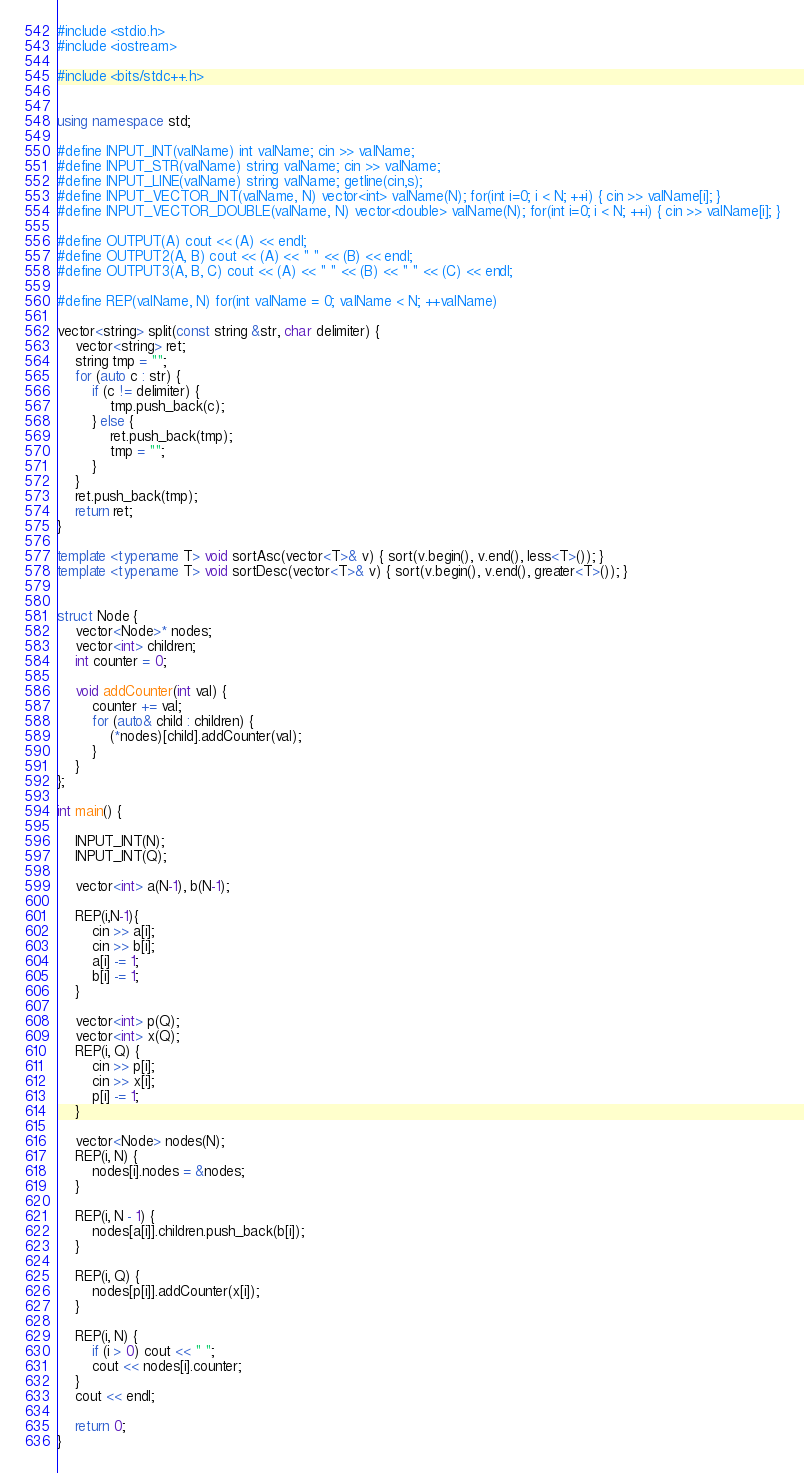Convert code to text. <code><loc_0><loc_0><loc_500><loc_500><_C++_>#include <stdio.h>
#include <iostream>

#include <bits/stdc++.h>


using namespace std;

#define INPUT_INT(valName) int valName; cin >> valName;
#define INPUT_STR(valName) string valName; cin >> valName;
#define INPUT_LINE(valName) string valName; getline(cin,s);
#define INPUT_VECTOR_INT(valName, N) vector<int> valName(N); for(int i=0; i < N; ++i) { cin >> valName[i]; }
#define INPUT_VECTOR_DOUBLE(valName, N) vector<double> valName(N); for(int i=0; i < N; ++i) { cin >> valName[i]; }

#define OUTPUT(A) cout << (A) << endl;
#define OUTPUT2(A, B) cout << (A) << " " << (B) << endl;
#define OUTPUT3(A, B, C) cout << (A) << " " << (B) << " " << (C) << endl;

#define REP(valName, N) for(int valName = 0; valName < N; ++valName)

vector<string> split(const string &str, char delimiter) {
	vector<string> ret;
	string tmp = "";
	for (auto c : str) {
		if (c != delimiter) {
			tmp.push_back(c);
		} else {
			ret.push_back(tmp);
			tmp = "";
		}
	}
	ret.push_back(tmp);
	return ret;
}

template <typename T> void sortAsc(vector<T>& v) { sort(v.begin(), v.end(), less<T>()); }
template <typename T> void sortDesc(vector<T>& v) { sort(v.begin(), v.end(), greater<T>()); }


struct Node {
	vector<Node>* nodes;
	vector<int> children;
	int counter = 0;

	void addCounter(int val) {
		counter += val;
		for (auto& child : children) {
			(*nodes)[child].addCounter(val);
		}
	}
};

int main() {

	INPUT_INT(N);
	INPUT_INT(Q);

	vector<int> a(N-1), b(N-1);

	REP(i,N-1){
		cin >> a[i];
		cin >> b[i];
		a[i] -= 1;
		b[i] -= 1;
	}

	vector<int> p(Q);
	vector<int> x(Q);
	REP(i, Q) {
		cin >> p[i];
		cin >> x[i];
		p[i] -= 1;
	}

	vector<Node> nodes(N);
	REP(i, N) {
		nodes[i].nodes = &nodes;
	}

	REP(i, N - 1) {
		nodes[a[i]].children.push_back(b[i]);
	}

	REP(i, Q) {
		nodes[p[i]].addCounter(x[i]);
	}

	REP(i, N) {
		if (i > 0) cout << " ";
		cout << nodes[i].counter;
	}
	cout << endl;

	return 0;
}</code> 